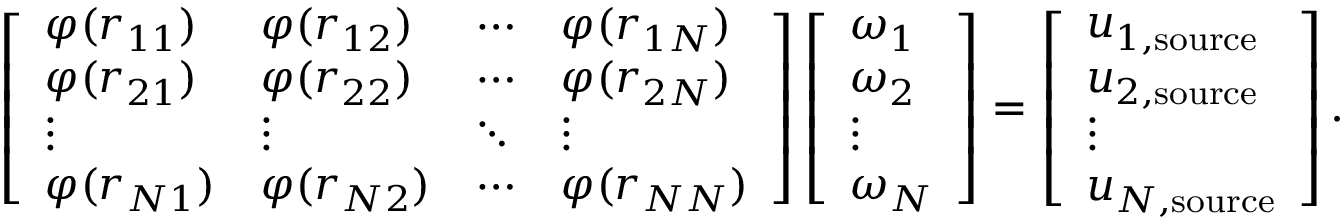Convert formula to latex. <formula><loc_0><loc_0><loc_500><loc_500>\left [ \begin{array} { l l l l } { \varphi ( r _ { 1 1 } ) } & { \varphi ( r _ { 1 2 } ) } & { \cdots } & { \varphi ( r _ { 1 N } ) } \\ { \varphi ( r _ { 2 1 } ) } & { \varphi ( r _ { 2 2 } ) } & { \cdots } & { \varphi ( r _ { 2 N } ) } \\ { \vdots } & { \vdots } & { \ddots } & { \vdots } \\ { \varphi ( r _ { N 1 } ) } & { \varphi ( r _ { N 2 } ) } & { \cdots } & { \varphi ( r _ { N N } ) } \end{array} \right ] \left [ \begin{array} { l } { \omega _ { 1 } } \\ { \omega _ { 2 } } \\ { \vdots } \\ { \omega _ { N } } \end{array} \right ] = \left [ \begin{array} { l } { u _ { 1 , s o u r c e } } \\ { u _ { 2 , s o u r c e } } \\ { \vdots } \\ { u _ { N , s o u r c e } } \end{array} \right ] .</formula> 